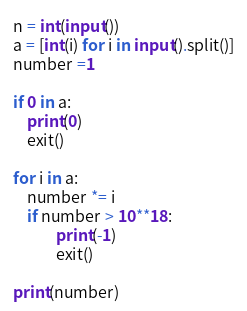Convert code to text. <code><loc_0><loc_0><loc_500><loc_500><_Python_>n = int(input())
a = [int(i) for i in input().split()]
number =1

if 0 in a:
    print(0)
    exit()

for i in a:
    number *= i
    if number > 10**18:
            print(-1)
            exit()

print(number)</code> 